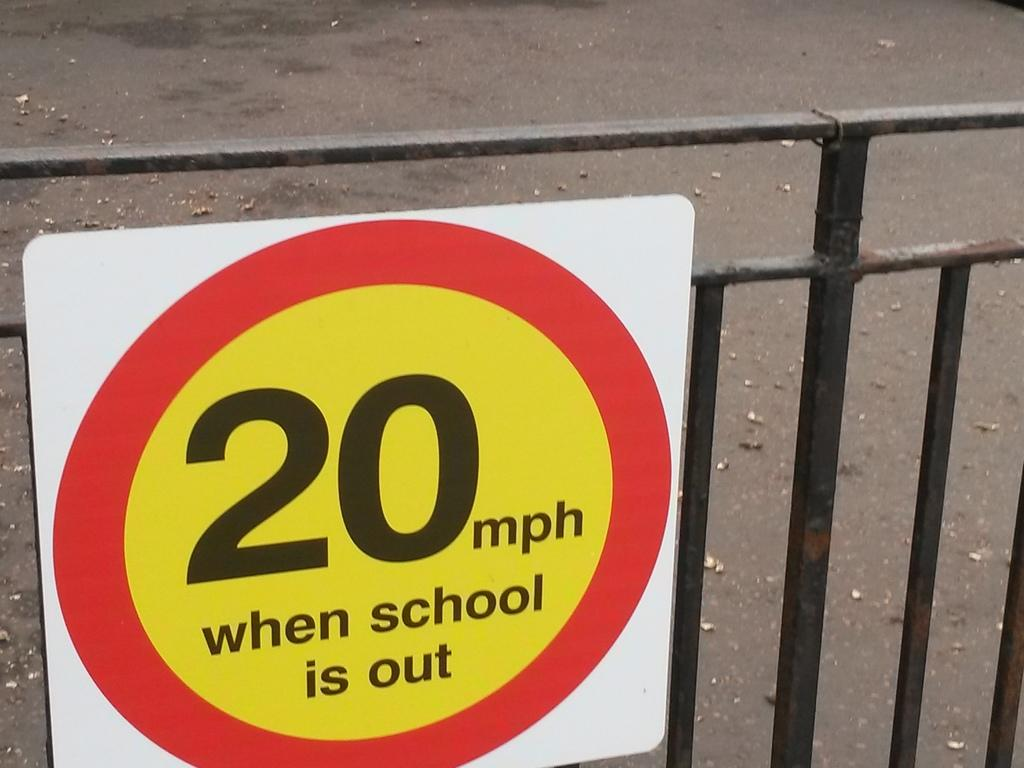Provide a one-sentence caption for the provided image. A red and yellow sign bares the message that the speed limit is 20 mph when school is out. 